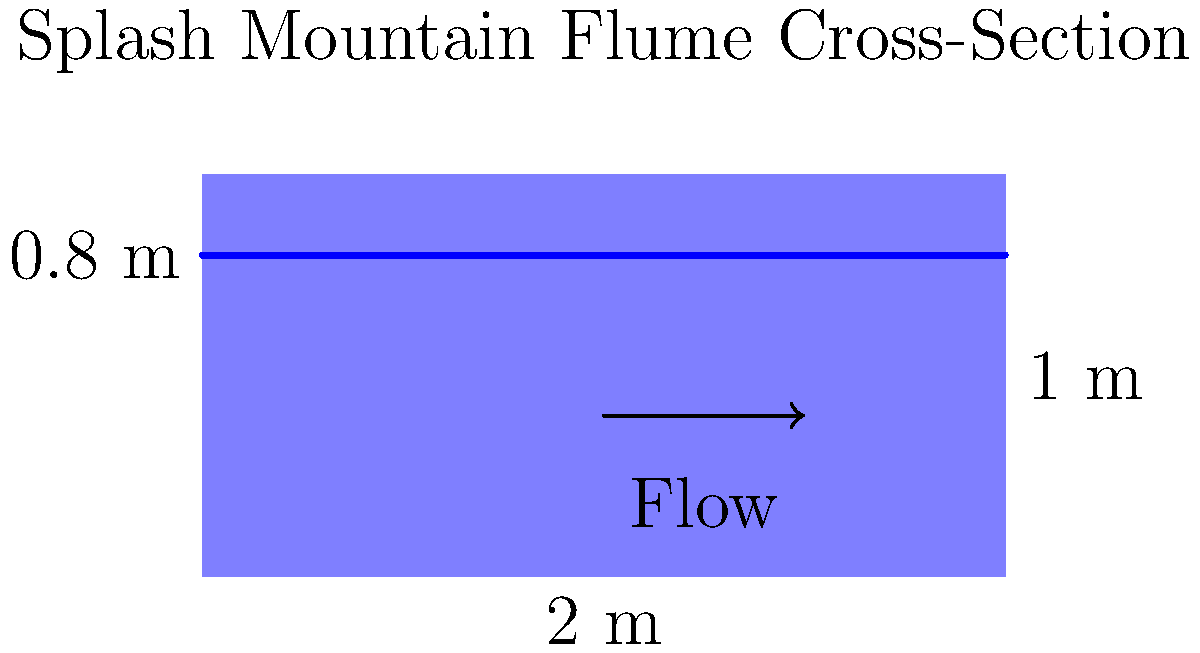In Splash Mountain's flume system, water flows through a rectangular channel with a width of 2 m and a depth of 1 m. If the water level is at 0.8 m and the average water velocity is 3 m/s, what is the volumetric flow rate in the flume? To solve this problem, we'll use the continuity equation for fluid flow:

$$ Q = A \cdot v $$

Where:
$Q$ = volumetric flow rate (m³/s)
$A$ = cross-sectional area of flow (m²)
$v$ = average velocity (m/s)

Steps to solve:

1. Calculate the cross-sectional area of flow:
   $A = \text{width} \times \text{water depth}$
   $A = 2 \text{ m} \times 0.8 \text{ m} = 1.6 \text{ m}^2$

2. Use the given average velocity:
   $v = 3 \text{ m/s}$

3. Apply the continuity equation:
   $Q = A \cdot v$
   $Q = 1.6 \text{ m}^2 \times 3 \text{ m/s}$
   $Q = 4.8 \text{ m}^3/\text{s}$

Therefore, the volumetric flow rate in the Splash Mountain flume is 4.8 m³/s.
Answer: 4.8 m³/s 